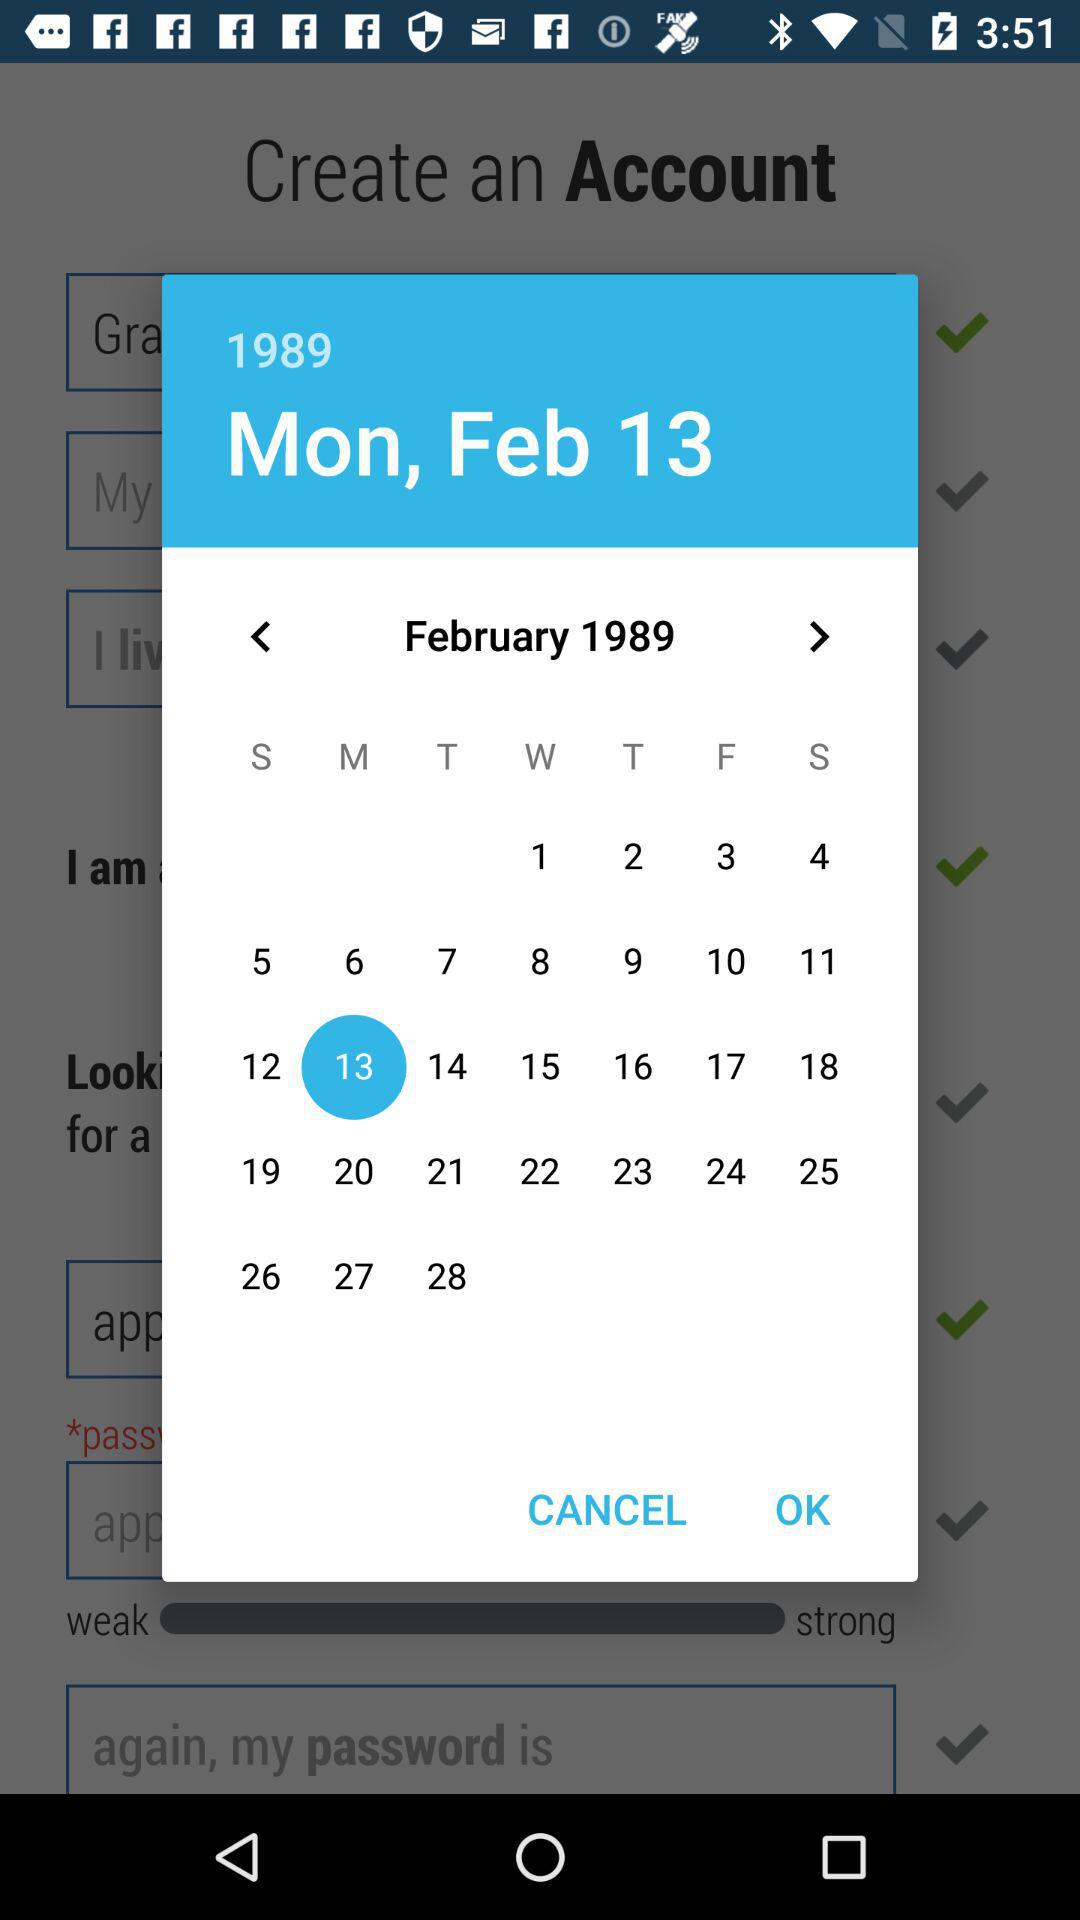What is the selected year? The selected year is 1989. 